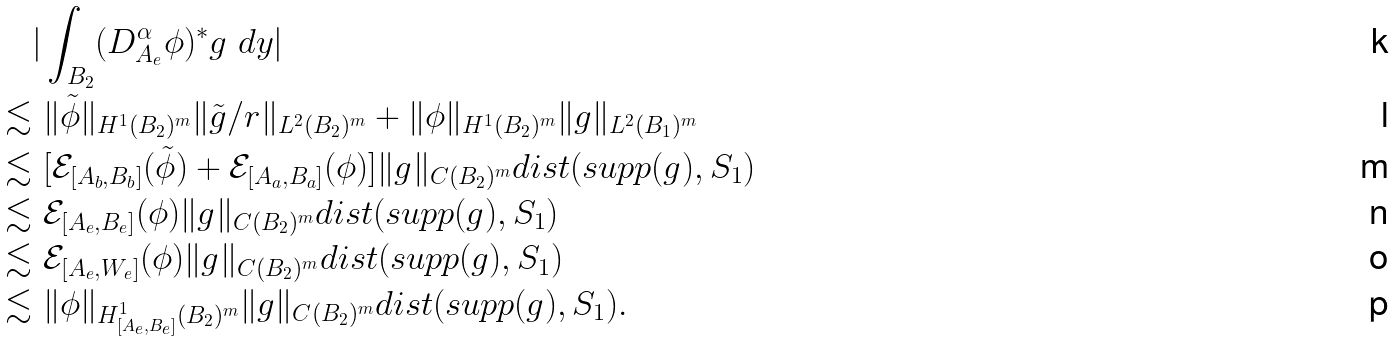<formula> <loc_0><loc_0><loc_500><loc_500>& | \int _ { B _ { 2 } } ( D _ { A _ { e } } ^ { \alpha } \phi ) ^ { * } g \ d y | \\ \lesssim & \ \| \tilde { \phi } \| _ { H ^ { 1 } ( B _ { 2 } ) ^ { m } } \| \tilde { g } / r \| _ { L ^ { 2 } ( B _ { 2 } ) ^ { m } } + \| \phi \| _ { H ^ { 1 } ( B _ { 2 } ) ^ { m } } \| g \| _ { L ^ { 2 } ( B _ { 1 } ) ^ { m } } \\ \lesssim & \ [ \mathcal { E } _ { [ A _ { b } , B _ { b } ] } ( \tilde { \phi } ) + \mathcal { E } _ { [ A _ { a } , B _ { a } ] } ( \phi ) ] \| g \| _ { C ( B _ { 2 } ) ^ { m } } d i s t ( s u p p ( g ) , S _ { 1 } ) \\ \lesssim & \ \mathcal { E } _ { [ A _ { e } , B _ { e } ] } ( \phi ) \| g \| _ { C ( B _ { 2 } ) ^ { m } } d i s t ( s u p p ( g ) , S _ { 1 } ) \\ \lesssim & \ \mathcal { E } _ { [ A _ { e } , W _ { e } ] } ( \phi ) \| g \| _ { C ( B _ { 2 } ) ^ { m } } d i s t ( s u p p ( g ) , S _ { 1 } ) \\ \lesssim & \ \| \phi \| _ { H ^ { 1 } _ { [ A _ { e } , B _ { e } ] } ( B _ { 2 } ) ^ { m } } \| g \| _ { C ( B _ { 2 } ) ^ { m } } d i s t ( s u p p ( g ) , S _ { 1 } ) .</formula> 